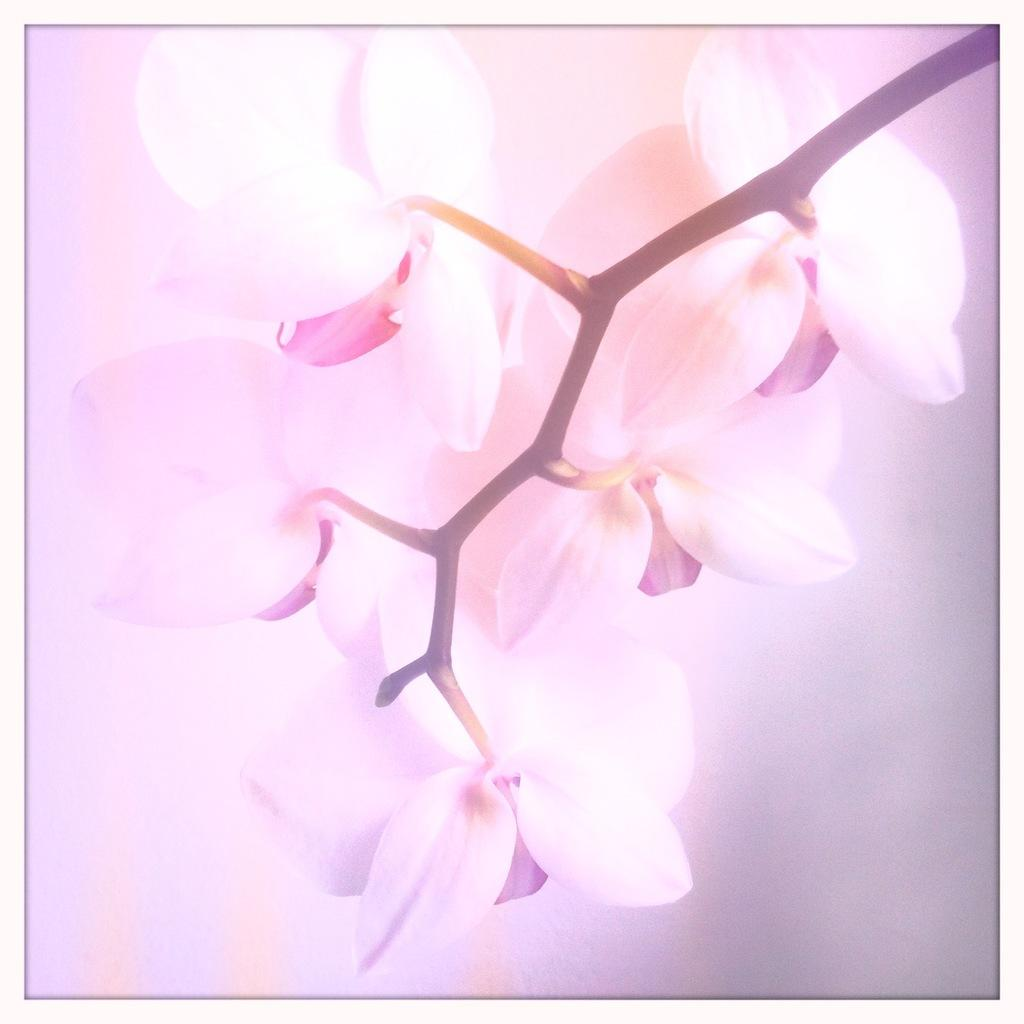What is the main subject of the image? The main subject of the image is flowers. Where are the flowers located in the image? The flowers are in the center of the image. What color are the flowers? The flowers are pink in color. How many teeth does the beggar have in the image? There is no beggar present in the image, so it is not possible to determine how many teeth they might have. 